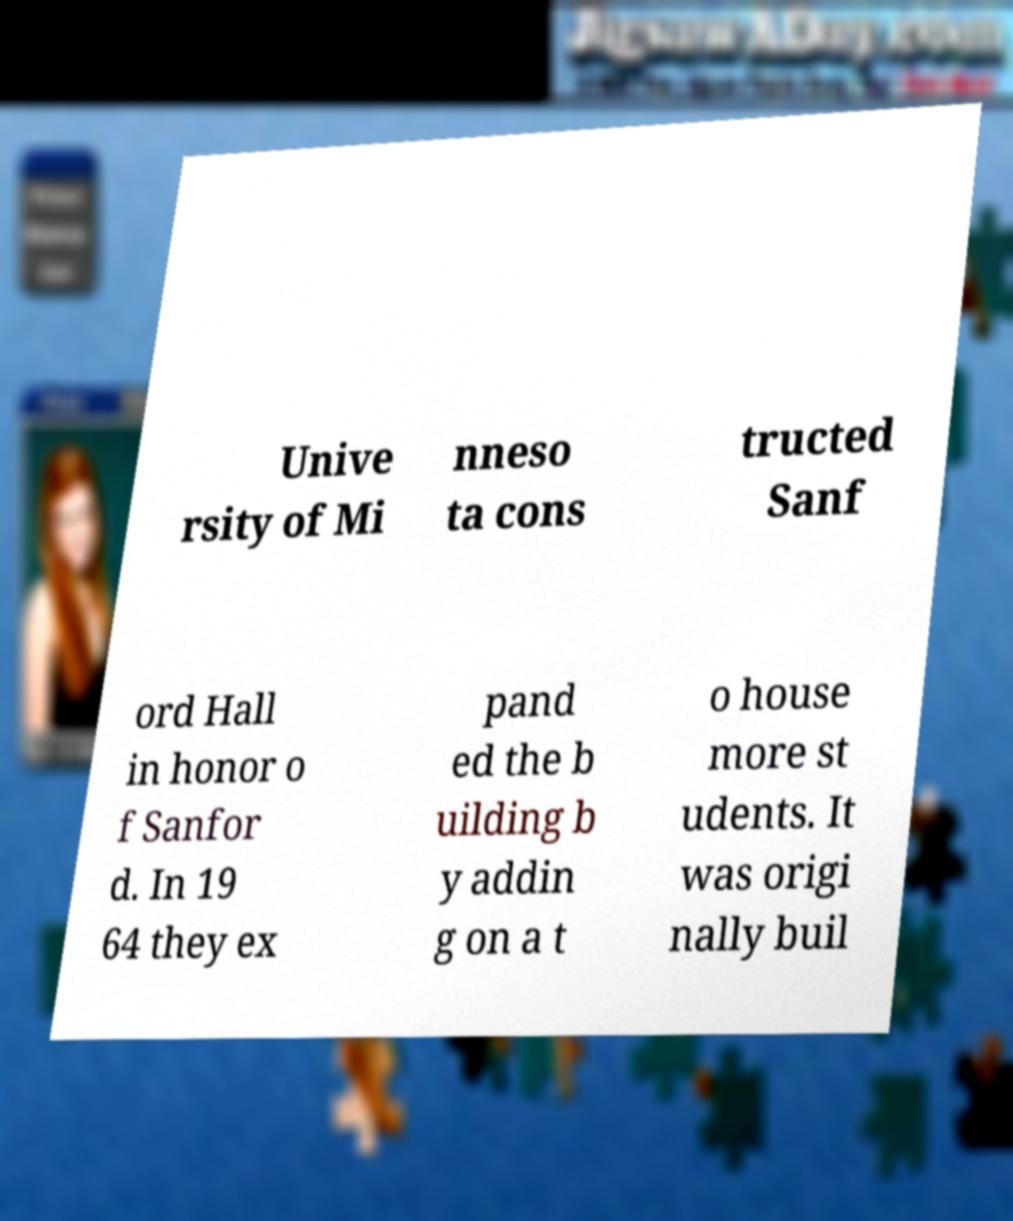What messages or text are displayed in this image? I need them in a readable, typed format. Unive rsity of Mi nneso ta cons tructed Sanf ord Hall in honor o f Sanfor d. In 19 64 they ex pand ed the b uilding b y addin g on a t o house more st udents. It was origi nally buil 